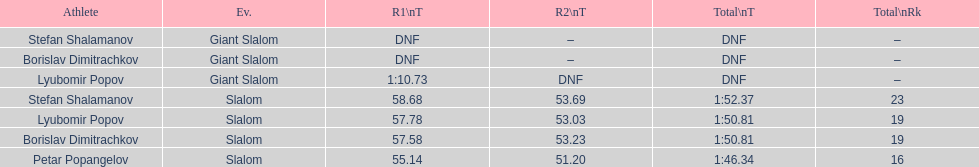Which athlete had a race time above 1:00? Lyubomir Popov. 